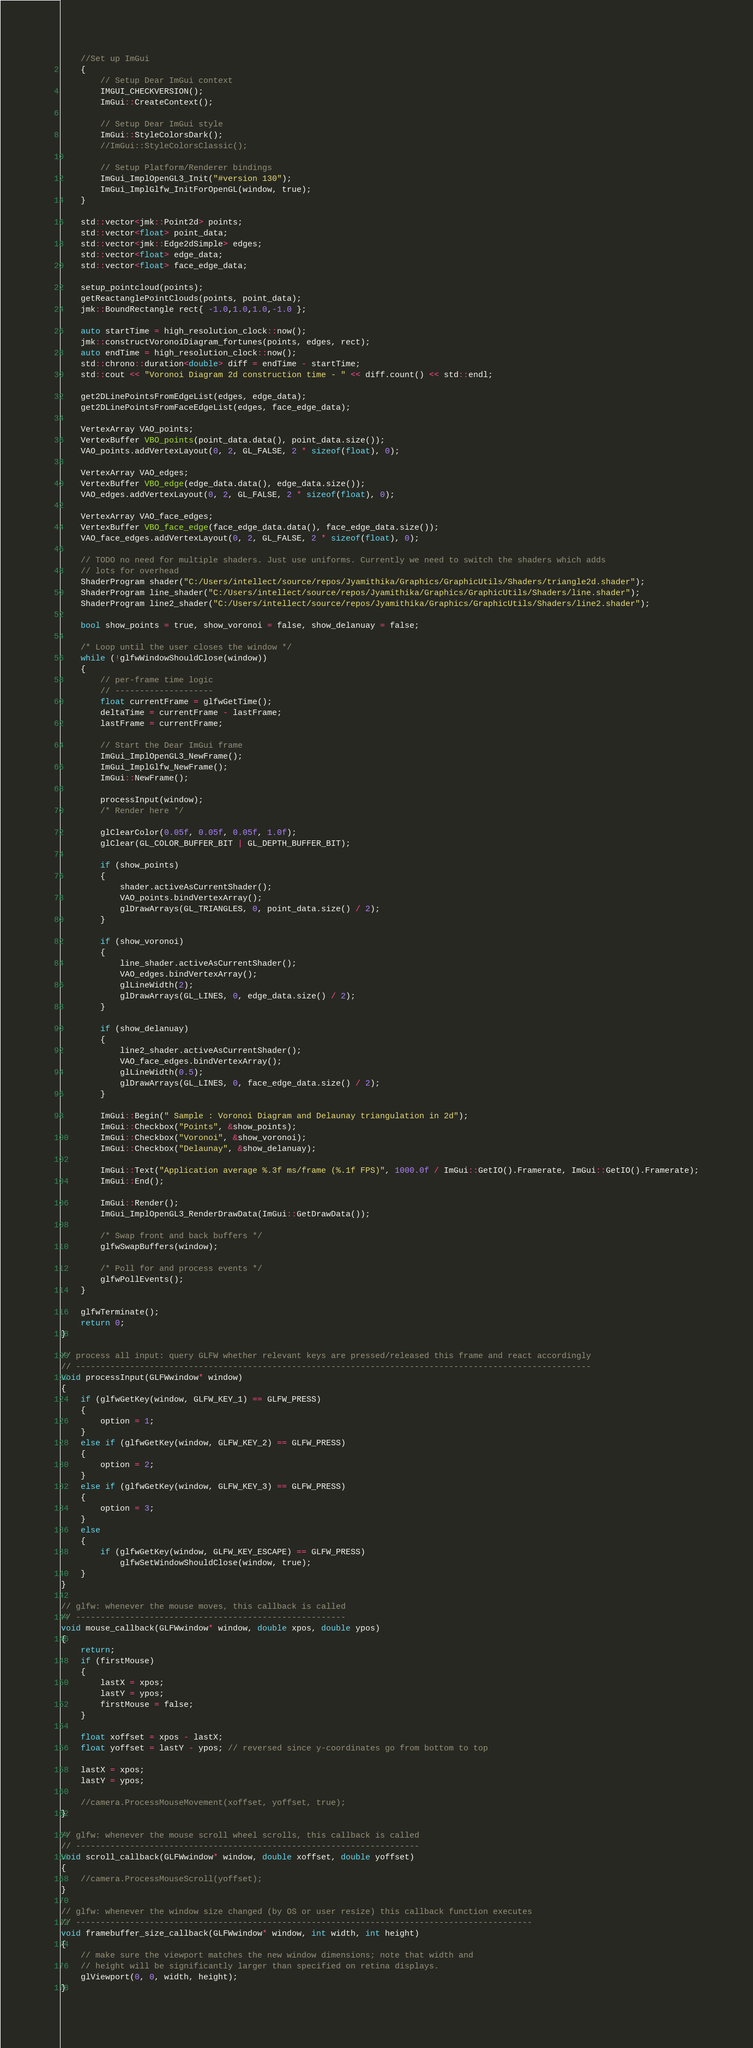<code> <loc_0><loc_0><loc_500><loc_500><_C++_>	//Set up ImGui
	{
		// Setup Dear ImGui context
		IMGUI_CHECKVERSION();
		ImGui::CreateContext();

		// Setup Dear ImGui style
		ImGui::StyleColorsDark();
		//ImGui::StyleColorsClassic();

		// Setup Platform/Renderer bindings
		ImGui_ImplOpenGL3_Init("#version 130");
		ImGui_ImplGlfw_InitForOpenGL(window, true);
	}

	std::vector<jmk::Point2d> points;
	std::vector<float> point_data;
	std::vector<jmk::Edge2dSimple> edges;
	std::vector<float> edge_data;
	std::vector<float> face_edge_data;

	setup_pointcloud(points);
	getReactanglePointClouds(points, point_data);
	jmk::BoundRectangle rect{ -1.0,1.0,1.0,-1.0 };
	
	auto startTime = high_resolution_clock::now();
	jmk::constructVoronoiDiagram_fortunes(points, edges, rect);	
	auto endTime = high_resolution_clock::now();
	std::chrono::duration<double> diff = endTime - startTime;
	std::cout << "Voronoi Diagram 2d construction time - " << diff.count() << std::endl;

	get2DLinePointsFromEdgeList(edges, edge_data);
	get2DLinePointsFromFaceEdgeList(edges, face_edge_data);

	VertexArray VAO_points;
	VertexBuffer VBO_points(point_data.data(), point_data.size());
	VAO_points.addVertexLayout(0, 2, GL_FALSE, 2 * sizeof(float), 0);

	VertexArray VAO_edges;
	VertexBuffer VBO_edge(edge_data.data(), edge_data.size());
	VAO_edges.addVertexLayout(0, 2, GL_FALSE, 2 * sizeof(float), 0);

	VertexArray VAO_face_edges;
	VertexBuffer VBO_face_edge(face_edge_data.data(), face_edge_data.size());
	VAO_face_edges.addVertexLayout(0, 2, GL_FALSE, 2 * sizeof(float), 0);

	// TODO no need for multiple shaders. Just use uniforms. Currently we need to switch the shaders which adds 
	// lots for overhead
	ShaderProgram shader("C:/Users/intellect/source/repos/Jyamithika/Graphics/GraphicUtils/Shaders/triangle2d.shader");
	ShaderProgram line_shader("C:/Users/intellect/source/repos/Jyamithika/Graphics/GraphicUtils/Shaders/line.shader");
	ShaderProgram line2_shader("C:/Users/intellect/source/repos/Jyamithika/Graphics/GraphicUtils/Shaders/line2.shader");

	bool show_points = true, show_voronoi = false, show_delanuay = false;

	/* Loop until the user closes the window */
	while (!glfwWindowShouldClose(window))
	{
		// per-frame time logic
		// --------------------
		float currentFrame = glfwGetTime();
		deltaTime = currentFrame - lastFrame;
		lastFrame = currentFrame;

		// Start the Dear ImGui frame
		ImGui_ImplOpenGL3_NewFrame();
		ImGui_ImplGlfw_NewFrame();
		ImGui::NewFrame();

		processInput(window);
		/* Render here */

		glClearColor(0.05f, 0.05f, 0.05f, 1.0f);
		glClear(GL_COLOR_BUFFER_BIT | GL_DEPTH_BUFFER_BIT);

		if (show_points)
		{
			shader.activeAsCurrentShader();
			VAO_points.bindVertexArray();
			glDrawArrays(GL_TRIANGLES, 0, point_data.size() / 2);
		}

		if (show_voronoi)
		{
			line_shader.activeAsCurrentShader();
			VAO_edges.bindVertexArray();
			glLineWidth(2);
			glDrawArrays(GL_LINES, 0, edge_data.size() / 2);
		}

		if (show_delanuay)
		{
			line2_shader.activeAsCurrentShader();
			VAO_face_edges.bindVertexArray();
			glLineWidth(0.5);
			glDrawArrays(GL_LINES, 0, face_edge_data.size() / 2);
		}

		ImGui::Begin(" Sample : Voronoi Diagram and Delaunay triangulation in 2d");
		ImGui::Checkbox("Points", &show_points);
		ImGui::Checkbox("Voronoi", &show_voronoi);
		ImGui::Checkbox("Delaunay", &show_delanuay);

		ImGui::Text("Application average %.3f ms/frame (%.1f FPS)", 1000.0f / ImGui::GetIO().Framerate, ImGui::GetIO().Framerate);
		ImGui::End();

		ImGui::Render();
		ImGui_ImplOpenGL3_RenderDrawData(ImGui::GetDrawData());

		/* Swap front and back buffers */
		glfwSwapBuffers(window);

		/* Poll for and process events */
		glfwPollEvents();
	}

	glfwTerminate();
	return 0;
}

// process all input: query GLFW whether relevant keys are pressed/released this frame and react accordingly
// ---------------------------------------------------------------------------------------------------------
void processInput(GLFWwindow* window)
{
	if (glfwGetKey(window, GLFW_KEY_1) == GLFW_PRESS)
	{
		option = 1;
	}
	else if (glfwGetKey(window, GLFW_KEY_2) == GLFW_PRESS)
	{
		option = 2;
	}
	else if (glfwGetKey(window, GLFW_KEY_3) == GLFW_PRESS)
	{
		option = 3;
	}
	else
	{
		if (glfwGetKey(window, GLFW_KEY_ESCAPE) == GLFW_PRESS)
			glfwSetWindowShouldClose(window, true);
	}
}

// glfw: whenever the mouse moves, this callback is called
// -------------------------------------------------------
void mouse_callback(GLFWwindow* window, double xpos, double ypos)
{
	return;
	if (firstMouse)
	{
		lastX = xpos;
		lastY = ypos;
		firstMouse = false;
	}

	float xoffset = xpos - lastX;
	float yoffset = lastY - ypos; // reversed since y-coordinates go from bottom to top

	lastX = xpos;
	lastY = ypos;

	//camera.ProcessMouseMovement(xoffset, yoffset, true);
}

// glfw: whenever the mouse scroll wheel scrolls, this callback is called
// ----------------------------------------------------------------------
void scroll_callback(GLFWwindow* window, double xoffset, double yoffset)
{
	//camera.ProcessMouseScroll(yoffset);
}

// glfw: whenever the window size changed (by OS or user resize) this callback function executes
// ---------------------------------------------------------------------------------------------
void framebuffer_size_callback(GLFWwindow* window, int width, int height)
{
	// make sure the viewport matches the new window dimensions; note that width and 
	// height will be significantly larger than specified on retina displays.
	glViewport(0, 0, width, height);
}</code> 